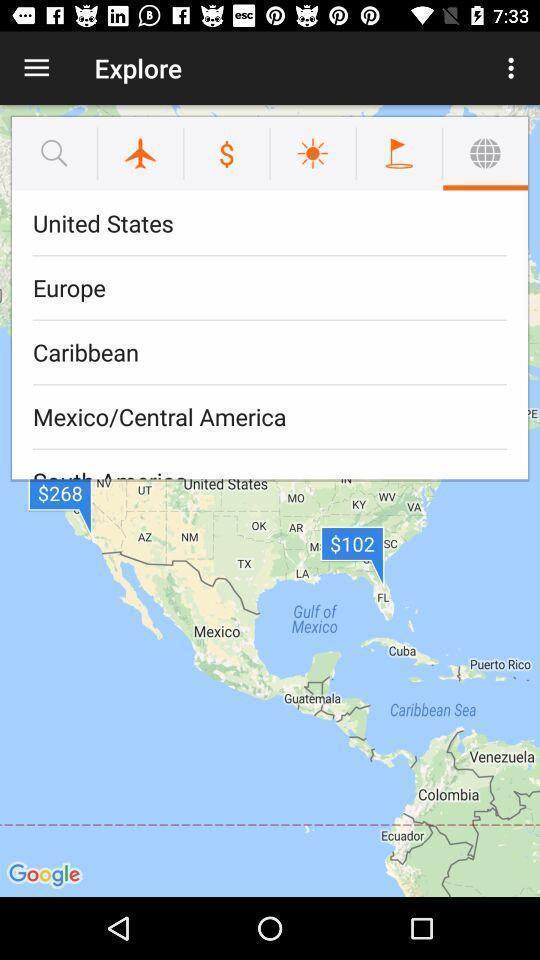What can you discern from this picture? Pop-up displaying country names on a map app. 